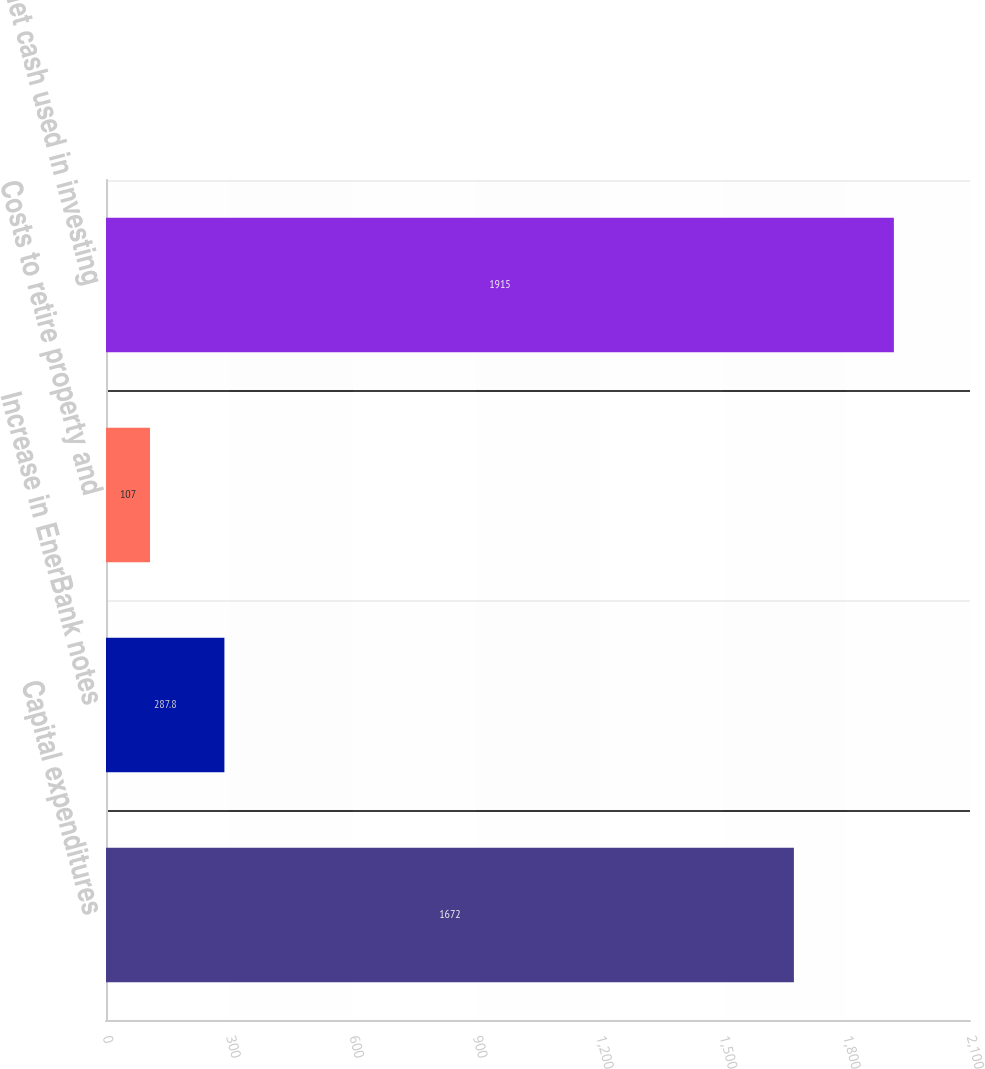Convert chart to OTSL. <chart><loc_0><loc_0><loc_500><loc_500><bar_chart><fcel>Capital expenditures<fcel>Increase in EnerBank notes<fcel>Costs to retire property and<fcel>Net cash used in investing<nl><fcel>1672<fcel>287.8<fcel>107<fcel>1915<nl></chart> 